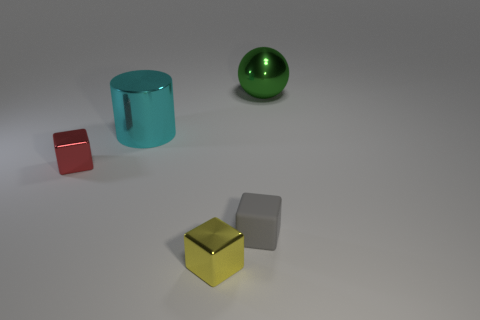Are there an equal number of small matte cubes behind the ball and small red metal objects right of the small red block?
Keep it short and to the point. Yes. There is a thing in front of the gray object; does it have the same shape as the gray rubber object?
Your answer should be very brief. Yes. There is a green object; is its size the same as the shiny cube behind the matte cube?
Your answer should be compact. No. There is a tiny metallic object that is in front of the small gray object; is there a tiny yellow block that is behind it?
Your answer should be very brief. No. What is the shape of the small metal thing on the left side of the big object to the left of the big thing on the right side of the cyan shiny cylinder?
Ensure brevity in your answer.  Cube. What is the color of the shiny thing that is both on the left side of the gray cube and on the right side of the big cyan metal thing?
Ensure brevity in your answer.  Yellow. There is a metallic thing behind the cyan shiny object; what shape is it?
Provide a short and direct response. Sphere. The small yellow object that is made of the same material as the cyan object is what shape?
Make the answer very short. Cube. There is a tiny metal block to the right of the big shiny object in front of the large green metal thing; how many blocks are on the left side of it?
Keep it short and to the point. 1. Do the object to the right of the tiny gray thing and the metal cube to the right of the red metallic cube have the same size?
Offer a very short reply. No. 